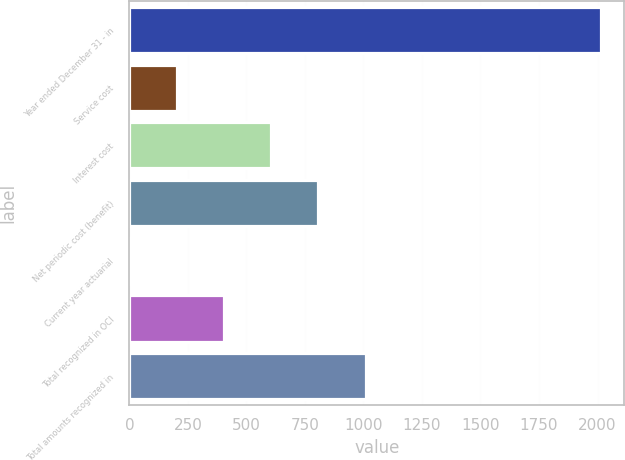Convert chart to OTSL. <chart><loc_0><loc_0><loc_500><loc_500><bar_chart><fcel>Year ended December 31 - in<fcel>Service cost<fcel>Interest cost<fcel>Net periodic cost (benefit)<fcel>Current year actuarial<fcel>Total recognized in OCI<fcel>Total amounts recognized in<nl><fcel>2014<fcel>205<fcel>607<fcel>808<fcel>4<fcel>406<fcel>1009<nl></chart> 